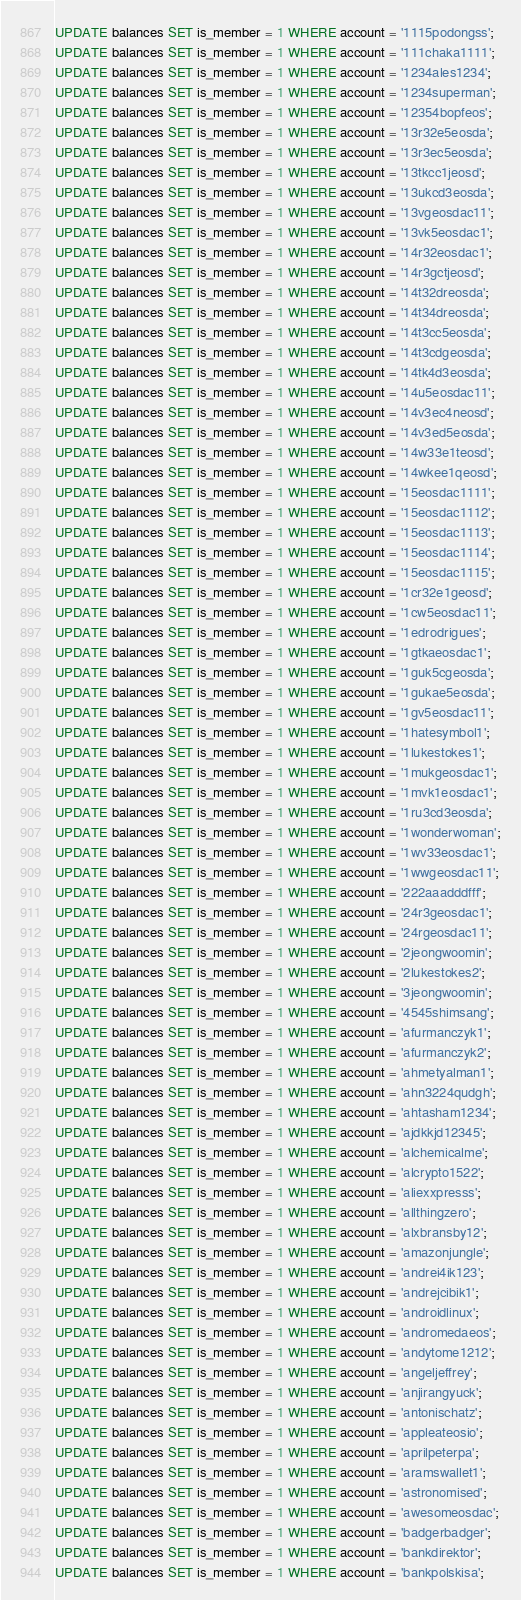<code> <loc_0><loc_0><loc_500><loc_500><_SQL_>UPDATE balances SET is_member = 1 WHERE account = '1115podongss';
UPDATE balances SET is_member = 1 WHERE account = '111chaka1111';
UPDATE balances SET is_member = 1 WHERE account = '1234ales1234';
UPDATE balances SET is_member = 1 WHERE account = '1234superman';
UPDATE balances SET is_member = 1 WHERE account = '12354bopfeos';
UPDATE balances SET is_member = 1 WHERE account = '13r32e5eosda';
UPDATE balances SET is_member = 1 WHERE account = '13r3ec5eosda';
UPDATE balances SET is_member = 1 WHERE account = '13tkcc1jeosd';
UPDATE balances SET is_member = 1 WHERE account = '13ukcd3eosda';
UPDATE balances SET is_member = 1 WHERE account = '13vgeosdac11';
UPDATE balances SET is_member = 1 WHERE account = '13vk5eosdac1';
UPDATE balances SET is_member = 1 WHERE account = '14r32eosdac1';
UPDATE balances SET is_member = 1 WHERE account = '14r3gctjeosd';
UPDATE balances SET is_member = 1 WHERE account = '14t32dreosda';
UPDATE balances SET is_member = 1 WHERE account = '14t34dreosda';
UPDATE balances SET is_member = 1 WHERE account = '14t3cc5eosda';
UPDATE balances SET is_member = 1 WHERE account = '14t3cdgeosda';
UPDATE balances SET is_member = 1 WHERE account = '14tk4d3eosda';
UPDATE balances SET is_member = 1 WHERE account = '14u5eosdac11';
UPDATE balances SET is_member = 1 WHERE account = '14v3ec4neosd';
UPDATE balances SET is_member = 1 WHERE account = '14v3ed5eosda';
UPDATE balances SET is_member = 1 WHERE account = '14w33e1teosd';
UPDATE balances SET is_member = 1 WHERE account = '14wkee1qeosd';
UPDATE balances SET is_member = 1 WHERE account = '15eosdac1111';
UPDATE balances SET is_member = 1 WHERE account = '15eosdac1112';
UPDATE balances SET is_member = 1 WHERE account = '15eosdac1113';
UPDATE balances SET is_member = 1 WHERE account = '15eosdac1114';
UPDATE balances SET is_member = 1 WHERE account = '15eosdac1115';
UPDATE balances SET is_member = 1 WHERE account = '1cr32e1geosd';
UPDATE balances SET is_member = 1 WHERE account = '1cw5eosdac11';
UPDATE balances SET is_member = 1 WHERE account = '1edrodrigues';
UPDATE balances SET is_member = 1 WHERE account = '1gtkaeosdac1';
UPDATE balances SET is_member = 1 WHERE account = '1guk5cgeosda';
UPDATE balances SET is_member = 1 WHERE account = '1gukae5eosda';
UPDATE balances SET is_member = 1 WHERE account = '1gv5eosdac11';
UPDATE balances SET is_member = 1 WHERE account = '1hatesymbol1';
UPDATE balances SET is_member = 1 WHERE account = '1lukestokes1';
UPDATE balances SET is_member = 1 WHERE account = '1mukgeosdac1';
UPDATE balances SET is_member = 1 WHERE account = '1mvk1eosdac1';
UPDATE balances SET is_member = 1 WHERE account = '1ru3cd3eosda';
UPDATE balances SET is_member = 1 WHERE account = '1wonderwoman';
UPDATE balances SET is_member = 1 WHERE account = '1wv33eosdac1';
UPDATE balances SET is_member = 1 WHERE account = '1wwgeosdac11';
UPDATE balances SET is_member = 1 WHERE account = '222aaadddfff';
UPDATE balances SET is_member = 1 WHERE account = '24r3geosdac1';
UPDATE balances SET is_member = 1 WHERE account = '24rgeosdac11';
UPDATE balances SET is_member = 1 WHERE account = '2jeongwoomin';
UPDATE balances SET is_member = 1 WHERE account = '2lukestokes2';
UPDATE balances SET is_member = 1 WHERE account = '3jeongwoomin';
UPDATE balances SET is_member = 1 WHERE account = '4545shimsang';
UPDATE balances SET is_member = 1 WHERE account = 'afurmanczyk1';
UPDATE balances SET is_member = 1 WHERE account = 'afurmanczyk2';
UPDATE balances SET is_member = 1 WHERE account = 'ahmetyalman1';
UPDATE balances SET is_member = 1 WHERE account = 'ahn3224qudgh';
UPDATE balances SET is_member = 1 WHERE account = 'ahtasham1234';
UPDATE balances SET is_member = 1 WHERE account = 'ajdkkjd12345';
UPDATE balances SET is_member = 1 WHERE account = 'alchemicalme';
UPDATE balances SET is_member = 1 WHERE account = 'alcrypto1522';
UPDATE balances SET is_member = 1 WHERE account = 'aliexxpresss';
UPDATE balances SET is_member = 1 WHERE account = 'allthingzero';
UPDATE balances SET is_member = 1 WHERE account = 'alxbransby12';
UPDATE balances SET is_member = 1 WHERE account = 'amazonjungle';
UPDATE balances SET is_member = 1 WHERE account = 'andrei4ik123';
UPDATE balances SET is_member = 1 WHERE account = 'andrejcibik1';
UPDATE balances SET is_member = 1 WHERE account = 'androidlinux';
UPDATE balances SET is_member = 1 WHERE account = 'andromedaeos';
UPDATE balances SET is_member = 1 WHERE account = 'andytome1212';
UPDATE balances SET is_member = 1 WHERE account = 'angeljeffrey';
UPDATE balances SET is_member = 1 WHERE account = 'anjirangyuck';
UPDATE balances SET is_member = 1 WHERE account = 'antonischatz';
UPDATE balances SET is_member = 1 WHERE account = 'appleateosio';
UPDATE balances SET is_member = 1 WHERE account = 'aprilpeterpa';
UPDATE balances SET is_member = 1 WHERE account = 'aramswallet1';
UPDATE balances SET is_member = 1 WHERE account = 'astronomised';
UPDATE balances SET is_member = 1 WHERE account = 'awesomeosdac';
UPDATE balances SET is_member = 1 WHERE account = 'badgerbadger';
UPDATE balances SET is_member = 1 WHERE account = 'bankdirektor';
UPDATE balances SET is_member = 1 WHERE account = 'bankpolskisa';</code> 